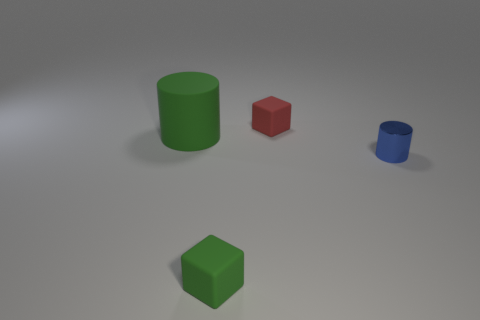Add 4 small purple metallic cylinders. How many objects exist? 8 Subtract 1 red blocks. How many objects are left? 3 Subtract all small metallic cylinders. Subtract all big yellow blocks. How many objects are left? 3 Add 1 red matte blocks. How many red matte blocks are left? 2 Add 2 yellow spheres. How many yellow spheres exist? 2 